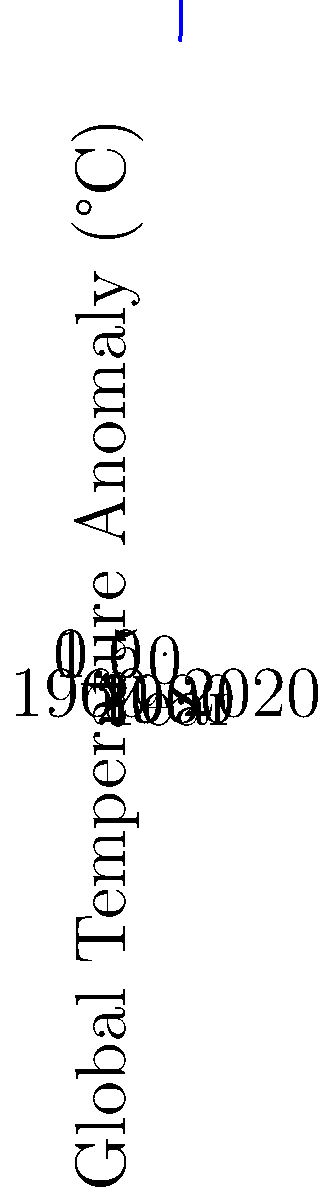Analyze the global temperature anomaly trend shown in the graph. What is the approximate rate of temperature increase per decade between 1980 and 2020, and what does this suggest about the pace of global warming? To answer this question, we need to follow these steps:

1. Identify the temperature anomalies for 1980 and 2020:
   - 1980: approximately 0.2°C
   - 2020: approximately 1.0°C

2. Calculate the total temperature change:
   $1.0°C - 0.2°C = 0.8°C$

3. Determine the time period:
   2020 - 1980 = 40 years

4. Calculate the rate of increase per decade:
   $\frac{0.8°C}{40 \text{ years}} \times 10 \text{ years/decade} = 0.2°C/\text{decade}$

5. Interpret the result:
   A 0.2°C increase per decade is considered a rapid rate of warming in climatological terms. This suggests that global warming is occurring at an accelerated pace, which is consistent with the scientific consensus on anthropogenic climate change.

6. Consider the curve's shape:
   The graph shows an accelerating trend, with the rate of increase becoming steeper in recent decades. This implies that the warming rate is not constant but is actually increasing over time, further emphasizing the urgency of addressing climate change.
Answer: Approximately 0.2°C/decade, indicating rapid and accelerating global warming. 